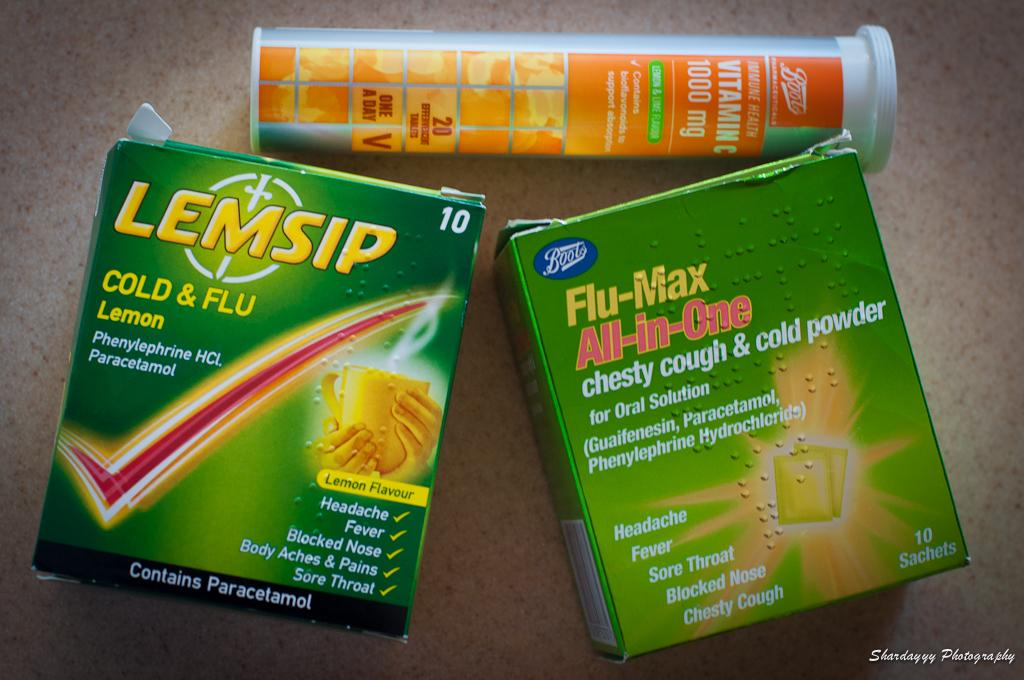How many green color boxes are in the image? There are two green color boxes in the image. What other color object can be seen in the image? There is an orange color bottle in the image. Are there any words or letters on the boxes and bottle? Yes, text is visible on the boxes and bottle. What month is depicted on the cactus in the image? There is no cactus present in the image, so it is not possible to determine what month might be depicted. 